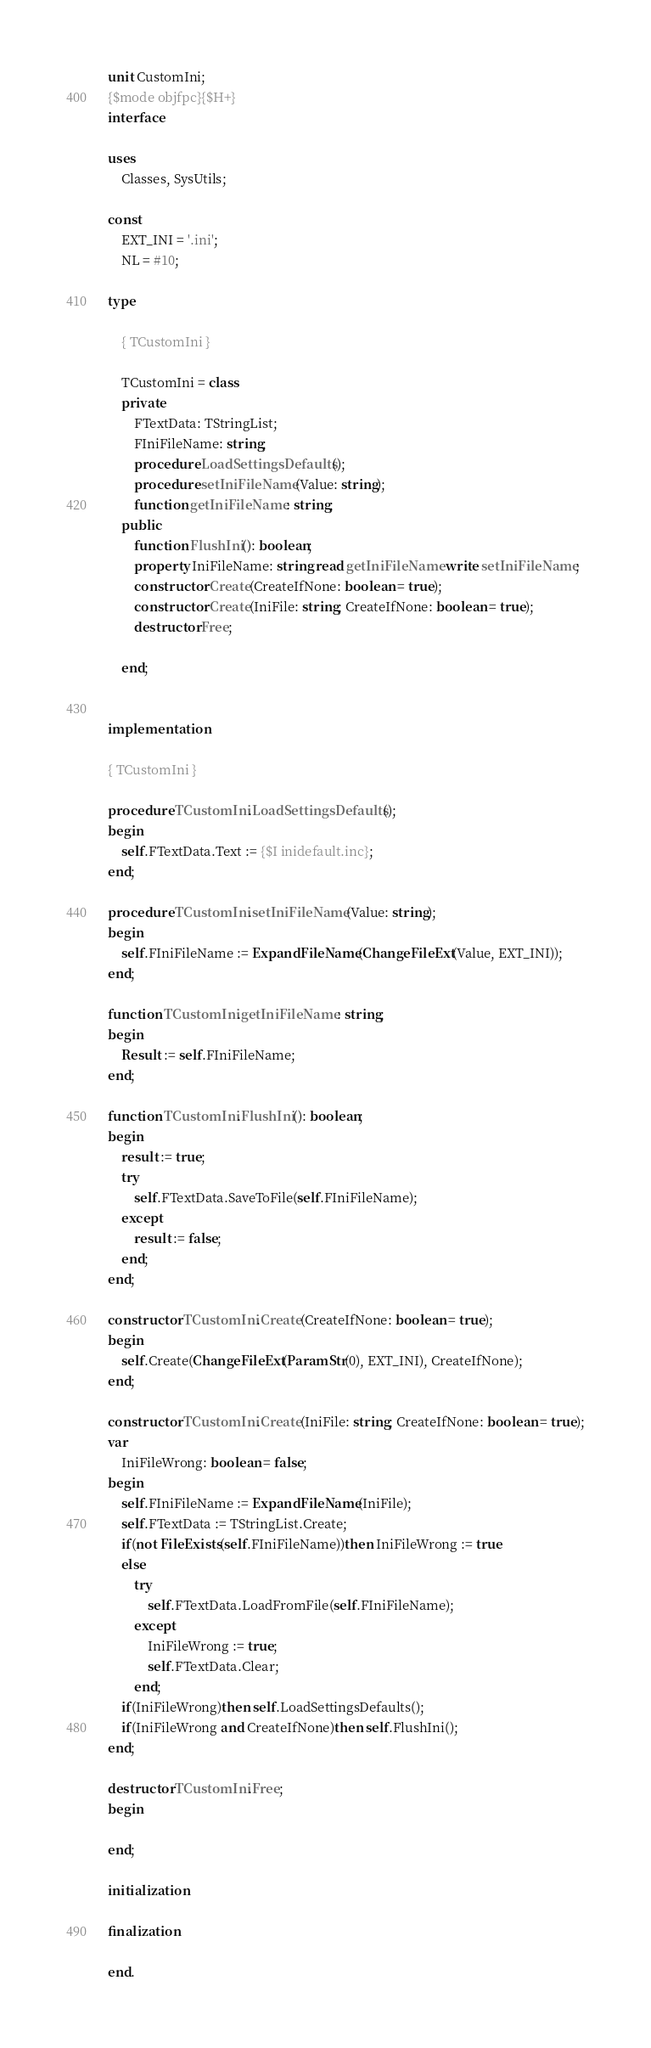Convert code to text. <code><loc_0><loc_0><loc_500><loc_500><_Pascal_>unit CustomIni;
{$mode objfpc}{$H+}
interface

uses
    Classes, SysUtils;

const
    EXT_INI = '.ini';
    NL = #10;

type

    { TCustomIni }

    TCustomIni = class
    private
        FTextData: TStringList;
        FIniFileName: string;
        procedure LoadSettingsDefaults();
        procedure setIniFileName(Value: string);
        function getIniFileName: string;
    public
        function FlushIni(): boolean;
        property IniFileName: string read getIniFileName write setIniFileName;
        constructor Create(CreateIfNone: boolean = true);
        constructor Create(IniFile: string; CreateIfNone: boolean = true);
        destructor Free;

    end;


implementation

{ TCustomIni }

procedure TCustomIni.LoadSettingsDefaults();
begin
    self.FTextData.Text := {$I inidefault.inc};
end;

procedure TCustomIni.setIniFileName(Value: string);
begin
    self.FIniFileName := ExpandFileName(ChangeFileExt(Value, EXT_INI));
end;

function TCustomIni.getIniFileName: string;
begin
    Result := self.FIniFileName;
end;

function TCustomIni.FlushIni(): boolean;
begin
    result := true;
    try
        self.FTextData.SaveToFile(self.FIniFileName);
    except
        result := false;
    end;
end;

constructor TCustomIni.Create(CreateIfNone: boolean = true);
begin
    self.Create(ChangeFileExt(ParamStr(0), EXT_INI), CreateIfNone);
end;

constructor TCustomIni.Create(IniFile: string; CreateIfNone: boolean = true);
var
    IniFileWrong: boolean = false;
begin
    self.FIniFileName := ExpandFileName(IniFile);
    self.FTextData := TStringList.Create;
    if(not FileExists(self.FIniFileName))then IniFileWrong := true
    else
        try
            self.FTextData.LoadFromFile(self.FIniFileName);
        except
            IniFileWrong := true;
            self.FTextData.Clear;
        end;
    if(IniFileWrong)then self.LoadSettingsDefaults();
    if(IniFileWrong and CreateIfNone)then self.FlushIni();
end;

destructor TCustomIni.Free;
begin

end;

initialization

finalization

end.

</code> 